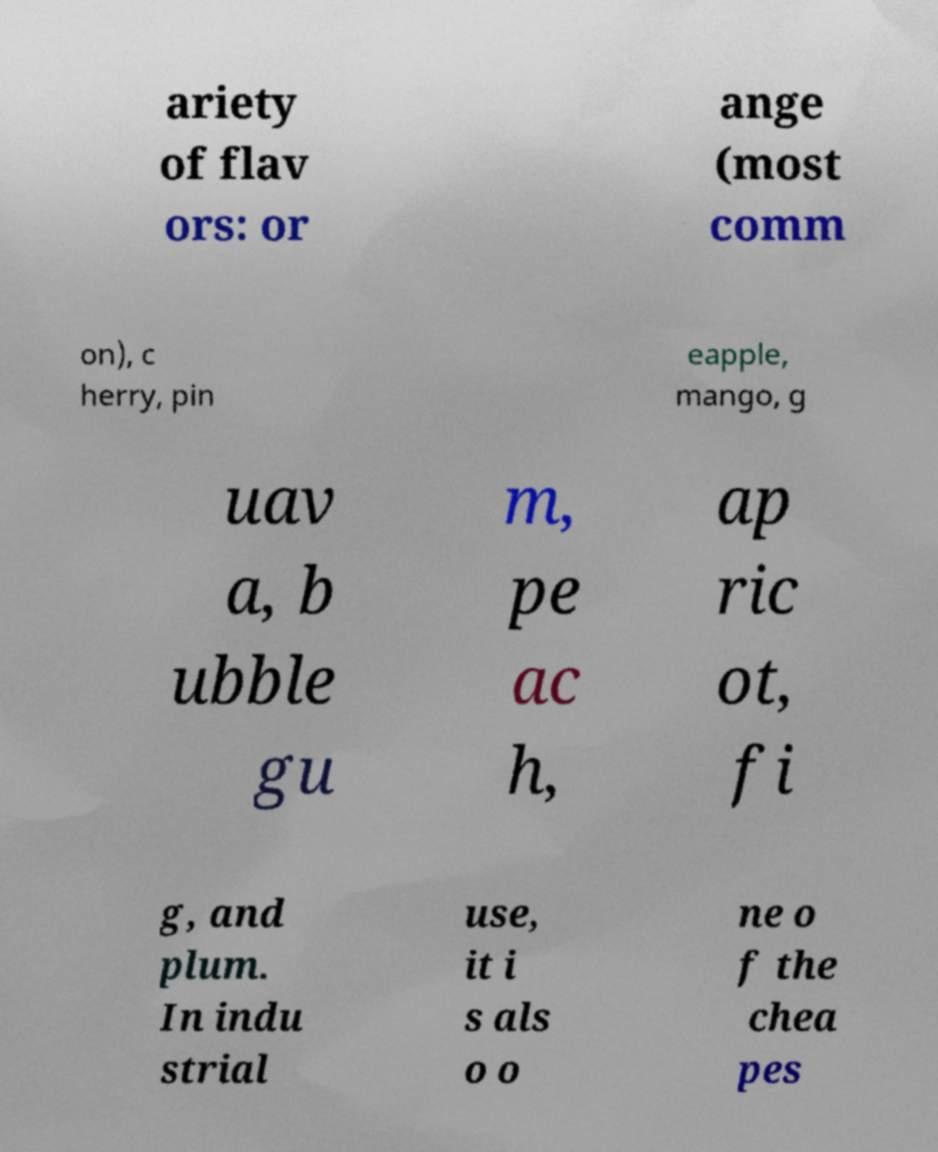What messages or text are displayed in this image? I need them in a readable, typed format. ariety of flav ors: or ange (most comm on), c herry, pin eapple, mango, g uav a, b ubble gu m, pe ac h, ap ric ot, fi g, and plum. In indu strial use, it i s als o o ne o f the chea pes 